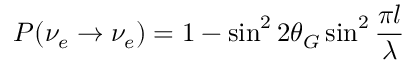Convert formula to latex. <formula><loc_0><loc_0><loc_500><loc_500>P ( \nu _ { e } \rightarrow \nu _ { e } ) = 1 - \sin ^ { 2 } 2 \theta _ { G } \sin ^ { 2 } \frac { \pi l } { \lambda }</formula> 